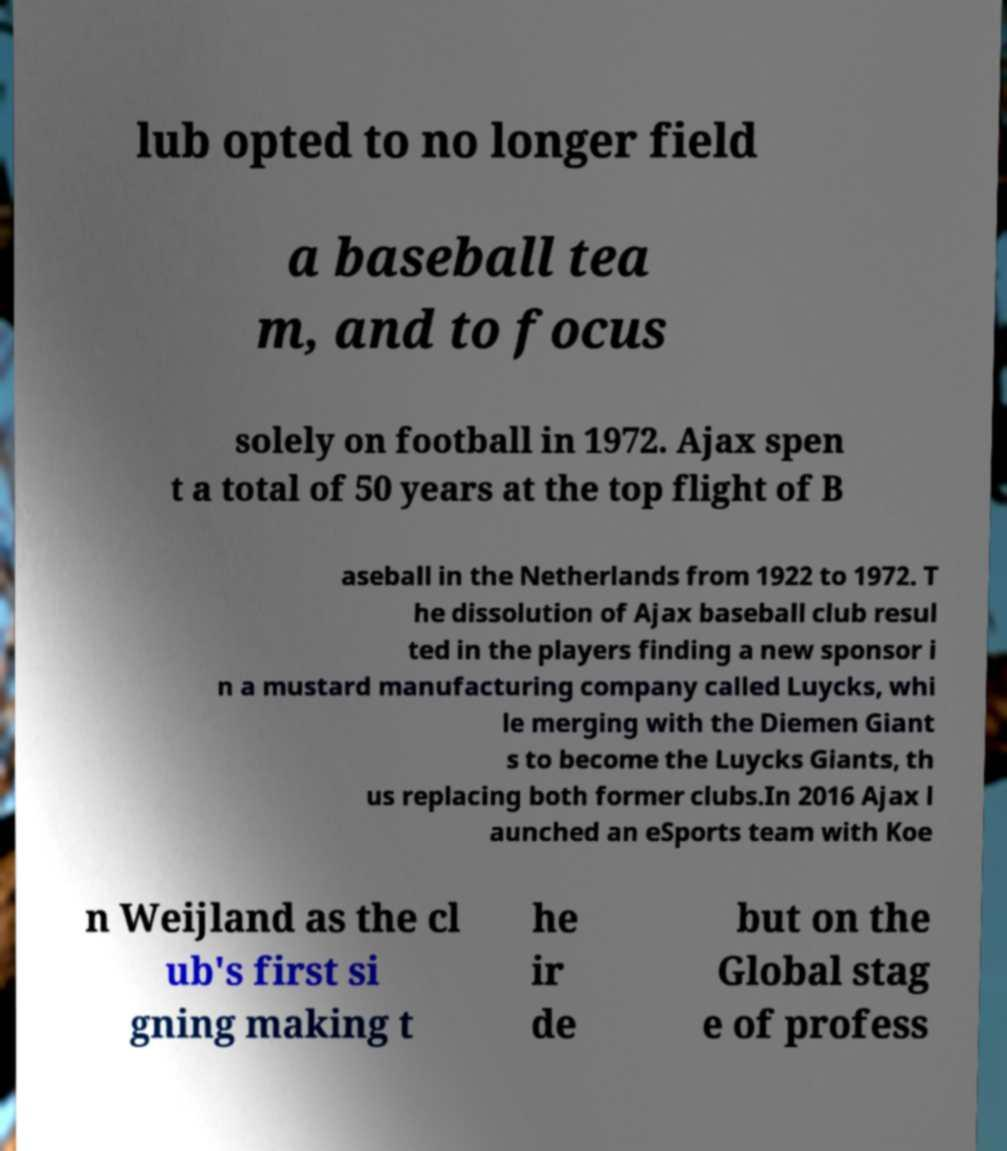Could you extract and type out the text from this image? lub opted to no longer field a baseball tea m, and to focus solely on football in 1972. Ajax spen t a total of 50 years at the top flight of B aseball in the Netherlands from 1922 to 1972. T he dissolution of Ajax baseball club resul ted in the players finding a new sponsor i n a mustard manufacturing company called Luycks, whi le merging with the Diemen Giant s to become the Luycks Giants, th us replacing both former clubs.In 2016 Ajax l aunched an eSports team with Koe n Weijland as the cl ub's first si gning making t he ir de but on the Global stag e of profess 